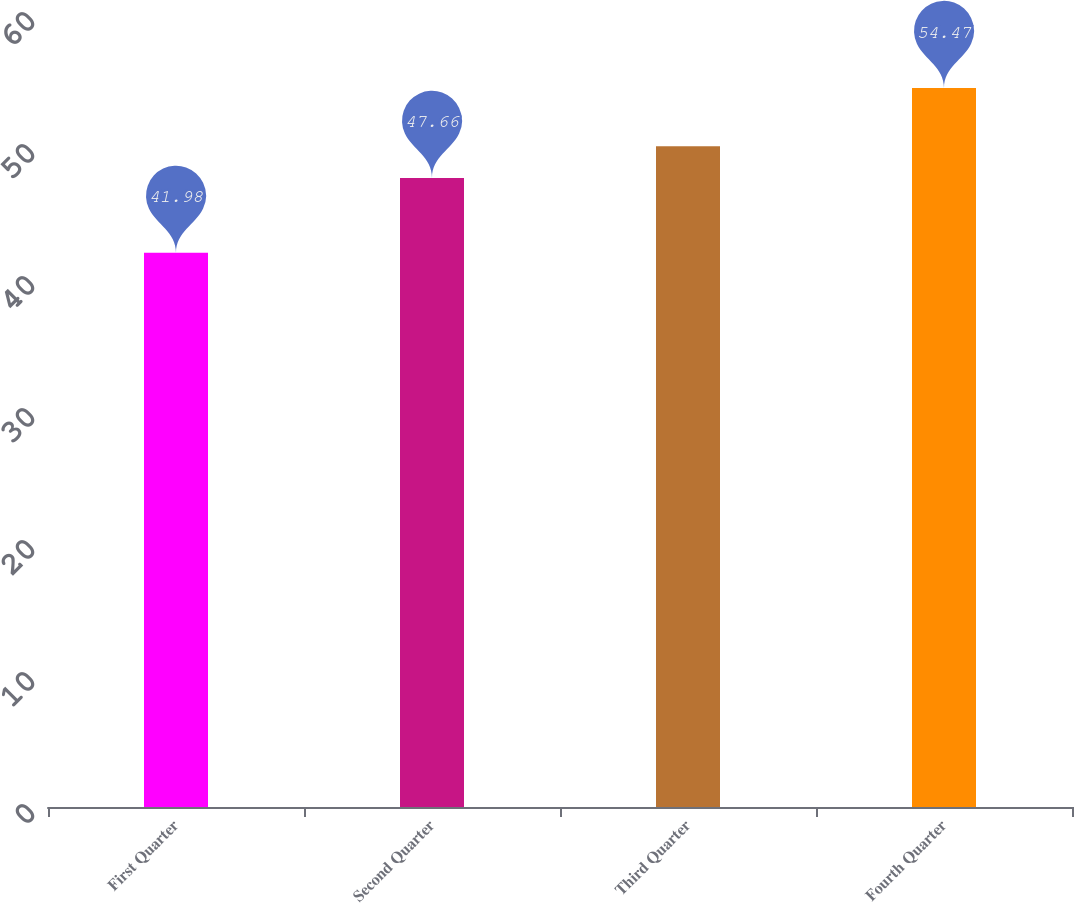<chart> <loc_0><loc_0><loc_500><loc_500><bar_chart><fcel>First Quarter<fcel>Second Quarter<fcel>Third Quarter<fcel>Fourth Quarter<nl><fcel>41.98<fcel>47.66<fcel>50.05<fcel>54.47<nl></chart> 